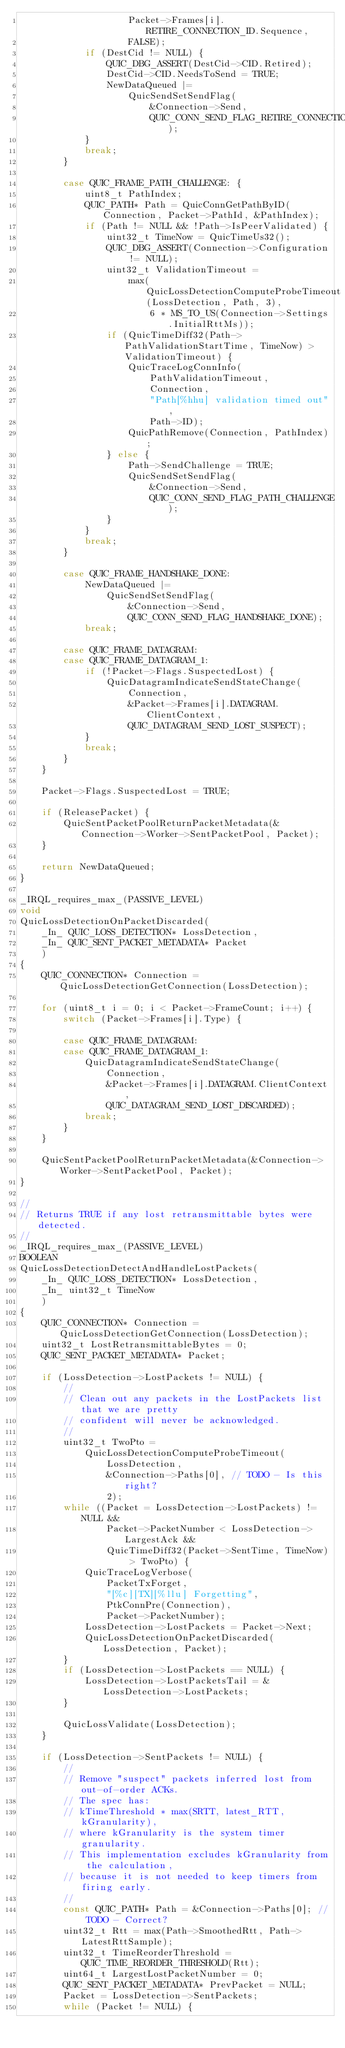<code> <loc_0><loc_0><loc_500><loc_500><_C_>                    Packet->Frames[i].RETIRE_CONNECTION_ID.Sequence,
                    FALSE);
            if (DestCid != NULL) {
                QUIC_DBG_ASSERT(DestCid->CID.Retired);
                DestCid->CID.NeedsToSend = TRUE;
                NewDataQueued |=
                    QuicSendSetSendFlag(
                        &Connection->Send,
                        QUIC_CONN_SEND_FLAG_RETIRE_CONNECTION_ID);
            }
            break;
        }

        case QUIC_FRAME_PATH_CHALLENGE: {
            uint8_t PathIndex;
            QUIC_PATH* Path = QuicConnGetPathByID(Connection, Packet->PathId, &PathIndex);
            if (Path != NULL && !Path->IsPeerValidated) {
                uint32_t TimeNow = QuicTimeUs32();
                QUIC_DBG_ASSERT(Connection->Configuration != NULL);
                uint32_t ValidationTimeout =
                    max(QuicLossDetectionComputeProbeTimeout(LossDetection, Path, 3),
                        6 * MS_TO_US(Connection->Settings.InitialRttMs));
                if (QuicTimeDiff32(Path->PathValidationStartTime, TimeNow) > ValidationTimeout) {
                    QuicTraceLogConnInfo(
                        PathValidationTimeout,
                        Connection,
                        "Path[%hhu] validation timed out",
                        Path->ID);
                    QuicPathRemove(Connection, PathIndex);
                } else {
                    Path->SendChallenge = TRUE;
                    QuicSendSetSendFlag(
                        &Connection->Send,
                        QUIC_CONN_SEND_FLAG_PATH_CHALLENGE);
                }
            }
            break;
        }

        case QUIC_FRAME_HANDSHAKE_DONE:
            NewDataQueued |=
                QuicSendSetSendFlag(
                    &Connection->Send,
                    QUIC_CONN_SEND_FLAG_HANDSHAKE_DONE);
            break;

        case QUIC_FRAME_DATAGRAM:
        case QUIC_FRAME_DATAGRAM_1:
            if (!Packet->Flags.SuspectedLost) {
                QuicDatagramIndicateSendStateChange(
                    Connection,
                    &Packet->Frames[i].DATAGRAM.ClientContext,
                    QUIC_DATAGRAM_SEND_LOST_SUSPECT);
            }
            break;
        }
    }

    Packet->Flags.SuspectedLost = TRUE;

    if (ReleasePacket) {
        QuicSentPacketPoolReturnPacketMetadata(&Connection->Worker->SentPacketPool, Packet);
    }

    return NewDataQueued;
}

_IRQL_requires_max_(PASSIVE_LEVEL)
void
QuicLossDetectionOnPacketDiscarded(
    _In_ QUIC_LOSS_DETECTION* LossDetection,
    _In_ QUIC_SENT_PACKET_METADATA* Packet
    )
{
    QUIC_CONNECTION* Connection = QuicLossDetectionGetConnection(LossDetection);

    for (uint8_t i = 0; i < Packet->FrameCount; i++) {
        switch (Packet->Frames[i].Type) {

        case QUIC_FRAME_DATAGRAM:
        case QUIC_FRAME_DATAGRAM_1:
            QuicDatagramIndicateSendStateChange(
                Connection,
                &Packet->Frames[i].DATAGRAM.ClientContext,
                QUIC_DATAGRAM_SEND_LOST_DISCARDED);
            break;
        }
    }

    QuicSentPacketPoolReturnPacketMetadata(&Connection->Worker->SentPacketPool, Packet);
}

//
// Returns TRUE if any lost retransmittable bytes were detected.
//
_IRQL_requires_max_(PASSIVE_LEVEL)
BOOLEAN
QuicLossDetectionDetectAndHandleLostPackets(
    _In_ QUIC_LOSS_DETECTION* LossDetection,
    _In_ uint32_t TimeNow
    )
{
    QUIC_CONNECTION* Connection = QuicLossDetectionGetConnection(LossDetection);
    uint32_t LostRetransmittableBytes = 0;
    QUIC_SENT_PACKET_METADATA* Packet;

    if (LossDetection->LostPackets != NULL) {
        //
        // Clean out any packets in the LostPackets list that we are pretty
        // confident will never be acknowledged.
        //
        uint32_t TwoPto =
            QuicLossDetectionComputeProbeTimeout(
                LossDetection,
                &Connection->Paths[0], // TODO - Is this right?
                2);
        while ((Packet = LossDetection->LostPackets) != NULL &&
                Packet->PacketNumber < LossDetection->LargestAck &&
                QuicTimeDiff32(Packet->SentTime, TimeNow) > TwoPto) {
            QuicTraceLogVerbose(
                PacketTxForget,
                "[%c][TX][%llu] Forgetting",
                PtkConnPre(Connection),
                Packet->PacketNumber);
            LossDetection->LostPackets = Packet->Next;
            QuicLossDetectionOnPacketDiscarded(LossDetection, Packet);
        }
        if (LossDetection->LostPackets == NULL) {
            LossDetection->LostPacketsTail = &LossDetection->LostPackets;
        }

        QuicLossValidate(LossDetection);
    }

    if (LossDetection->SentPackets != NULL) {
        //
        // Remove "suspect" packets inferred lost from out-of-order ACKs.
        // The spec has:
        // kTimeThreshold * max(SRTT, latest_RTT, kGranularity),
        // where kGranularity is the system timer granularity.
        // This implementation excludes kGranularity from the calculation,
        // because it is not needed to keep timers from firing early.
        //
        const QUIC_PATH* Path = &Connection->Paths[0]; // TODO - Correct?
        uint32_t Rtt = max(Path->SmoothedRtt, Path->LatestRttSample);
        uint32_t TimeReorderThreshold = QUIC_TIME_REORDER_THRESHOLD(Rtt);
        uint64_t LargestLostPacketNumber = 0;
        QUIC_SENT_PACKET_METADATA* PrevPacket = NULL;
        Packet = LossDetection->SentPackets;
        while (Packet != NULL) {
</code> 